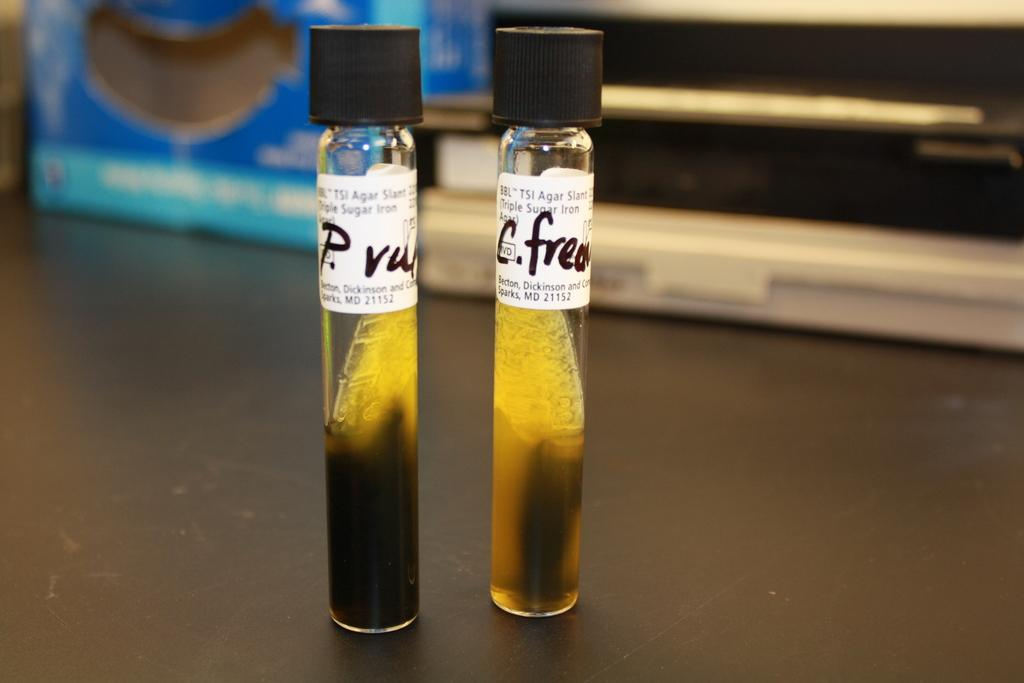<image>
Offer a succinct explanation of the picture presented. The bottles were made by Becton, Dickinson and Company. 